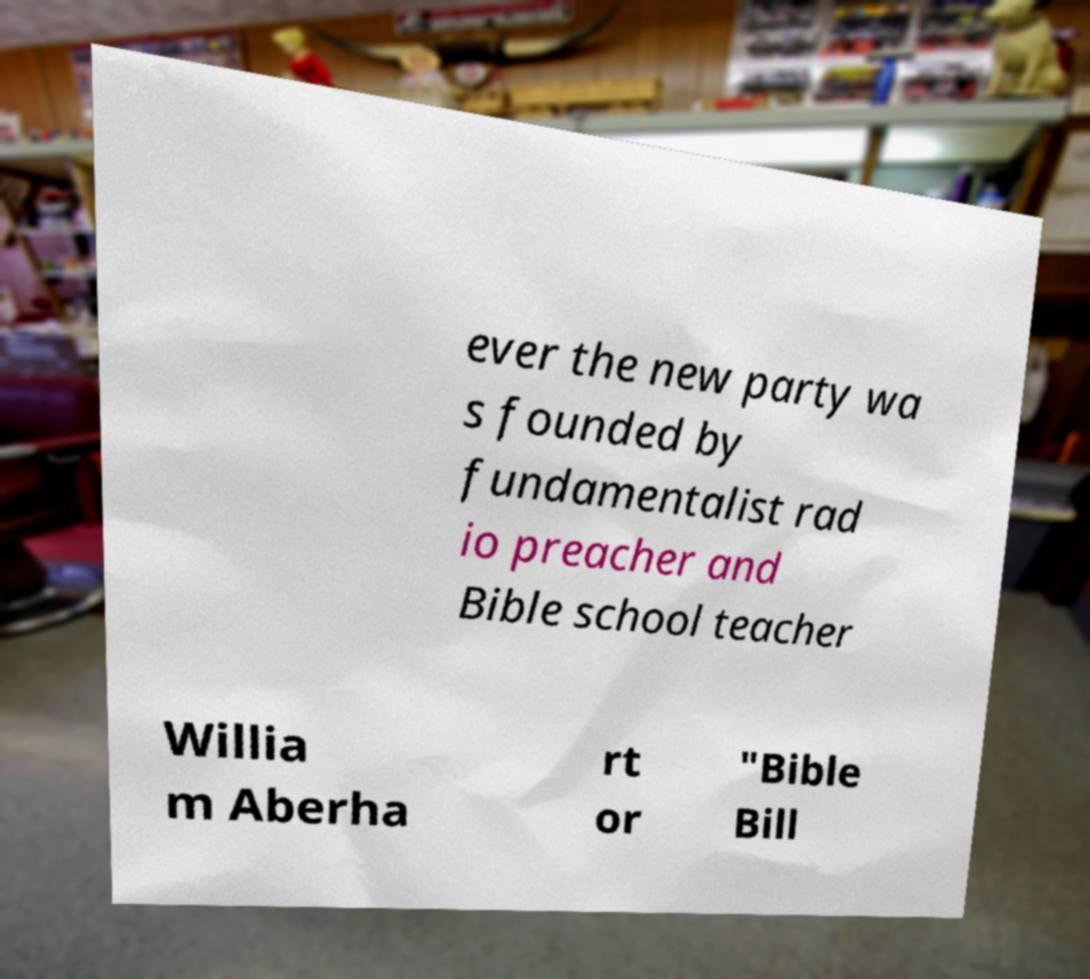For documentation purposes, I need the text within this image transcribed. Could you provide that? ever the new party wa s founded by fundamentalist rad io preacher and Bible school teacher Willia m Aberha rt or "Bible Bill 